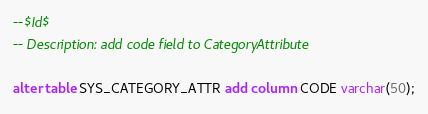Convert code to text. <code><loc_0><loc_0><loc_500><loc_500><_SQL_>--$Id$
-- Description: add code field to CategoryAttribute

alter table SYS_CATEGORY_ATTR add column CODE varchar(50);</code> 